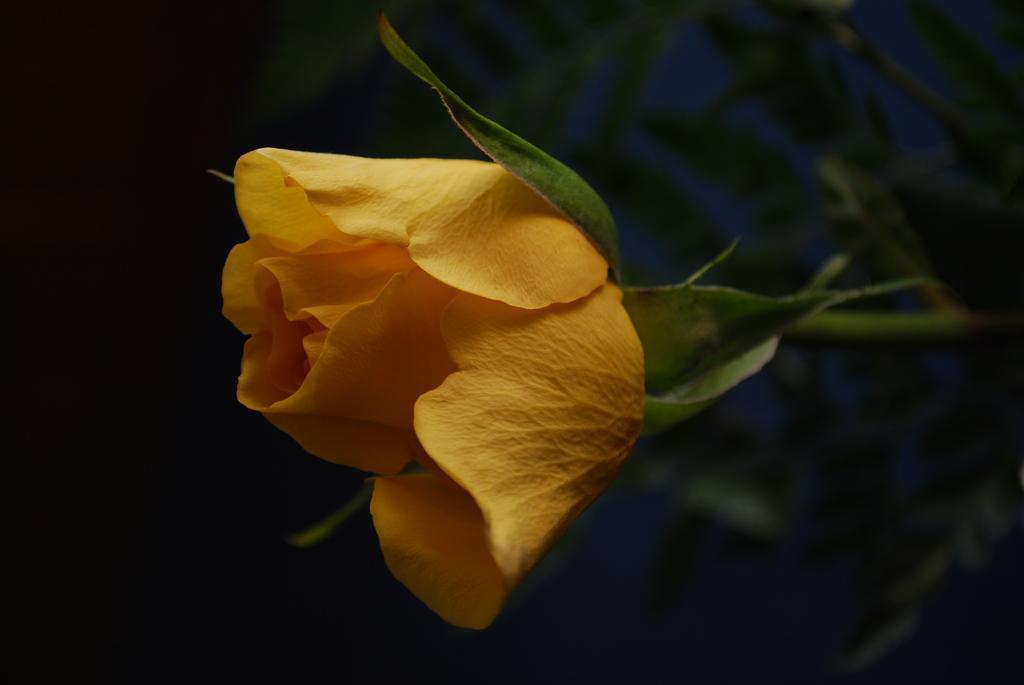Please provide a concise description of this image. In this image we can see a rose flower which is in yellow color. 